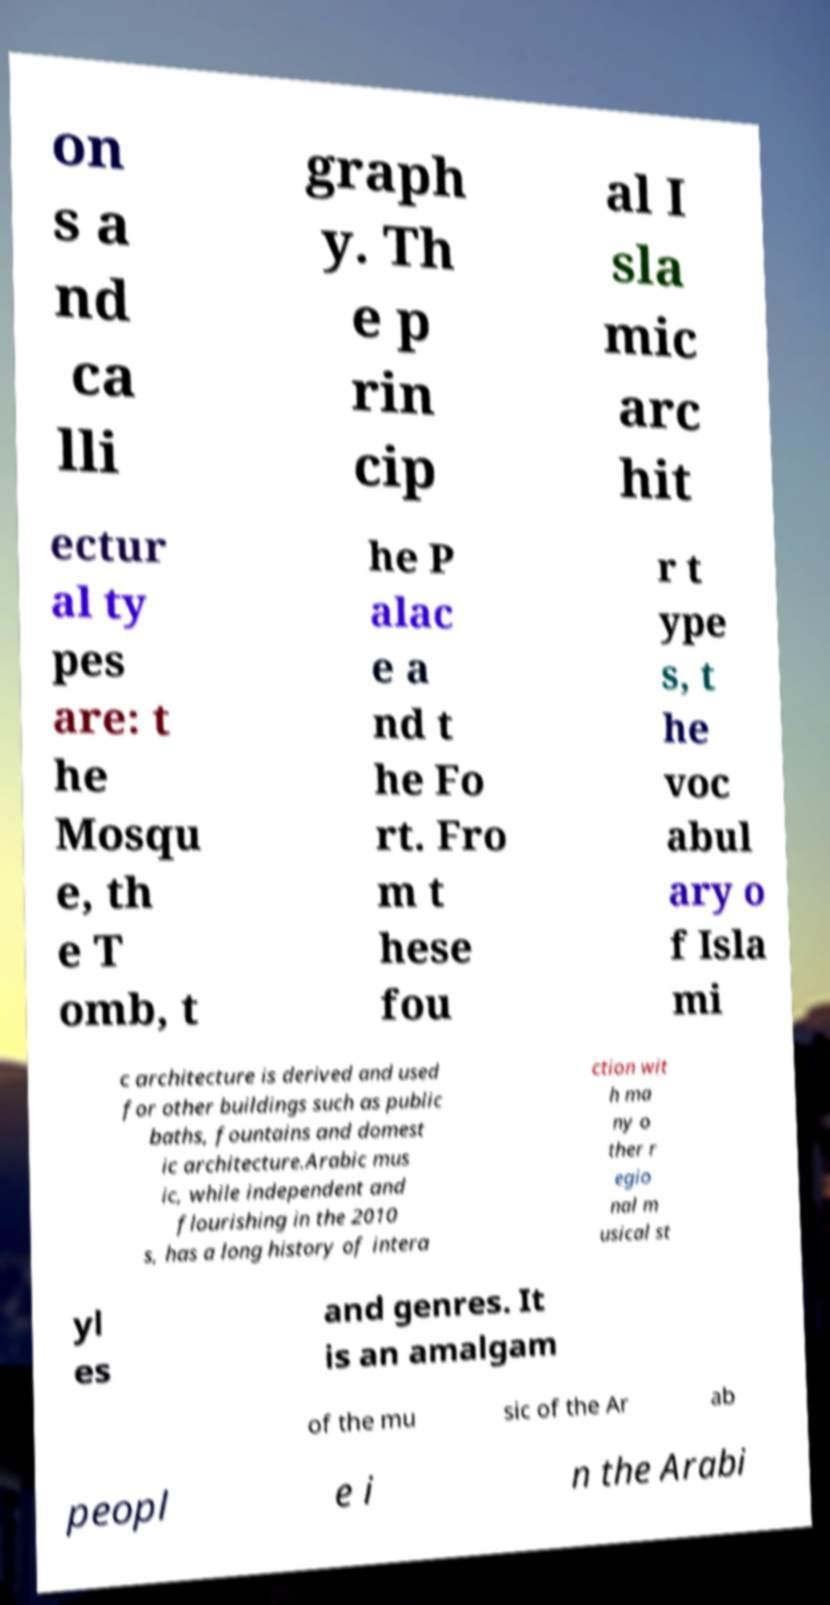Can you read and provide the text displayed in the image?This photo seems to have some interesting text. Can you extract and type it out for me? on s a nd ca lli graph y. Th e p rin cip al I sla mic arc hit ectur al ty pes are: t he Mosqu e, th e T omb, t he P alac e a nd t he Fo rt. Fro m t hese fou r t ype s, t he voc abul ary o f Isla mi c architecture is derived and used for other buildings such as public baths, fountains and domest ic architecture.Arabic mus ic, while independent and flourishing in the 2010 s, has a long history of intera ction wit h ma ny o ther r egio nal m usical st yl es and genres. It is an amalgam of the mu sic of the Ar ab peopl e i n the Arabi 